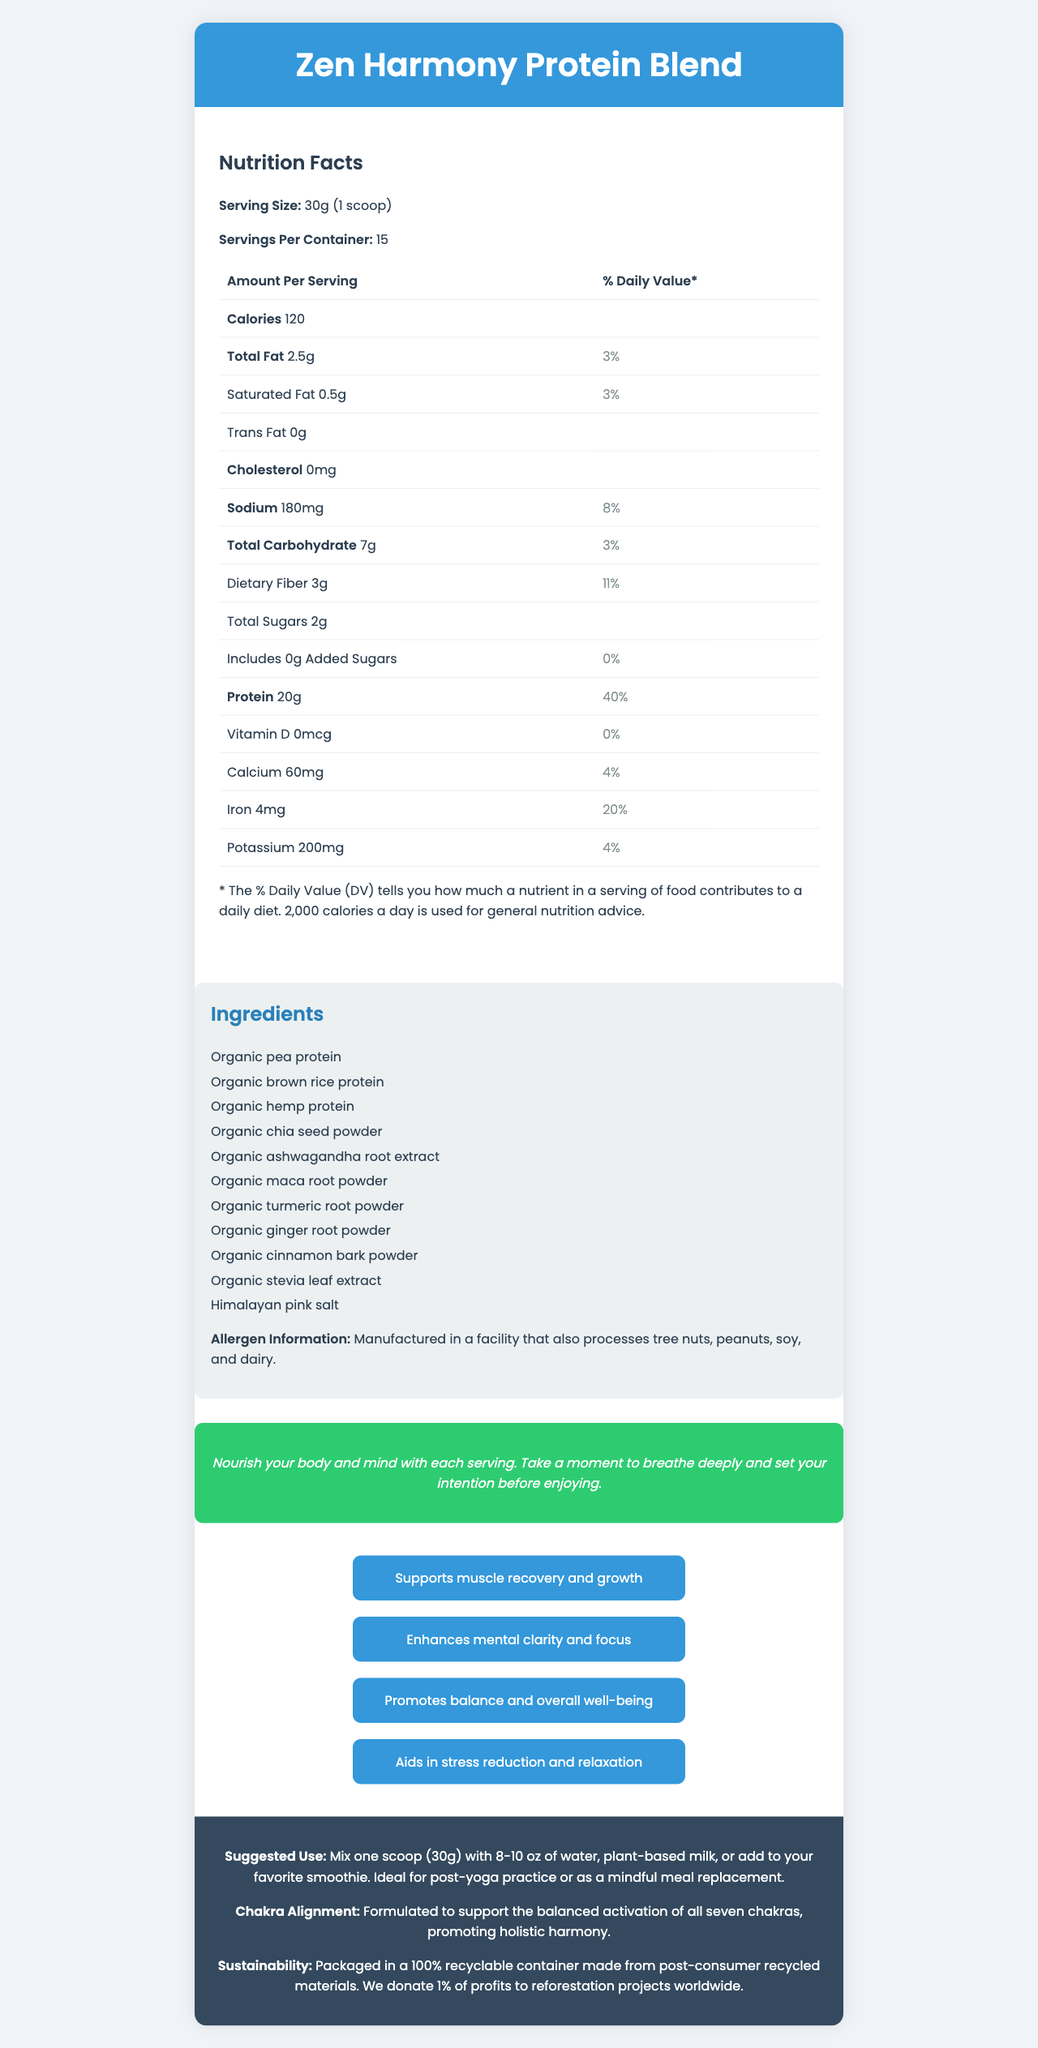What is the product name? The product name is displayed at the top of the document.
Answer: Zen Harmony Protein Blend How many servings are there per container? The document specifies that there are 15 servings per container.
Answer: 15 What is the serving size? The serving size is mentioned as 30g (1 scoop).
Answer: 30g (1 scoop) How many calories are there per serving? The document states that each serving contains 120 calories.
Answer: 120 What is the amount of protein per serving? The protein amount per serving is listed as 20g.
Answer: 20g What is the percentage of the daily value for protein? The protein daily value percentage is indicated as 40%.
Answer: 40% Where is the product manufactured? There is no information in the document regarding the manufacturing location.
Answer: Cannot be determined What is the amount of total carbohydrates per serving? The document states that there are 7g of total carbohydrates per serving.
Answer: 7g What is the percentage of daily value for dietary fiber? A. 8% B. 11% C. 20% D. 40% The daily value percentage for dietary fiber is listed as 11%.
Answer: B Which ingredient is not included in the Zen Harmony Protein Blend? A. Organic turmeric root powder B. Organic chia seed powder C. Organic wheat protein D. Organic ginger root powder Organic wheat protein is not mentioned in the list of ingredients.
Answer: C Does the product contain any cholesterol? The document specifies that the product contains 0mg of cholesterol.
Answer: No What is the sustainability note mentioned in the document? The sustainability note details the packaging material and the company's commitment to reforestation projects.
Answer: Packaged in a 100% recyclable container made from post-consumer recycled materials. We donate 1% of profits to reforestation projects worldwide. Summarize the main idea of the document. The document outlines the nutritional facts, ingredients, benefits, and suggested use of Zen Harmony Protein Blend, along with a focus on sustainability and mindfulness.
Answer: Zen Harmony Protein Blend is a plant-based protein powder that incorporates adaptogenic herbs and is designed to support muscle recovery, mental clarity, balance, and overall well-being. It contains 20g of protein per serving, has minimal sugars, and includes various organic ingredients. The product also emphasizes sustainability and mindful consumption. What should one do before enjoying the Zen Harmony Protein Blend? The mindfulness message in the document suggests doing this before consumption.
Answer: Take a moment to breathe deeply and set your intention. 